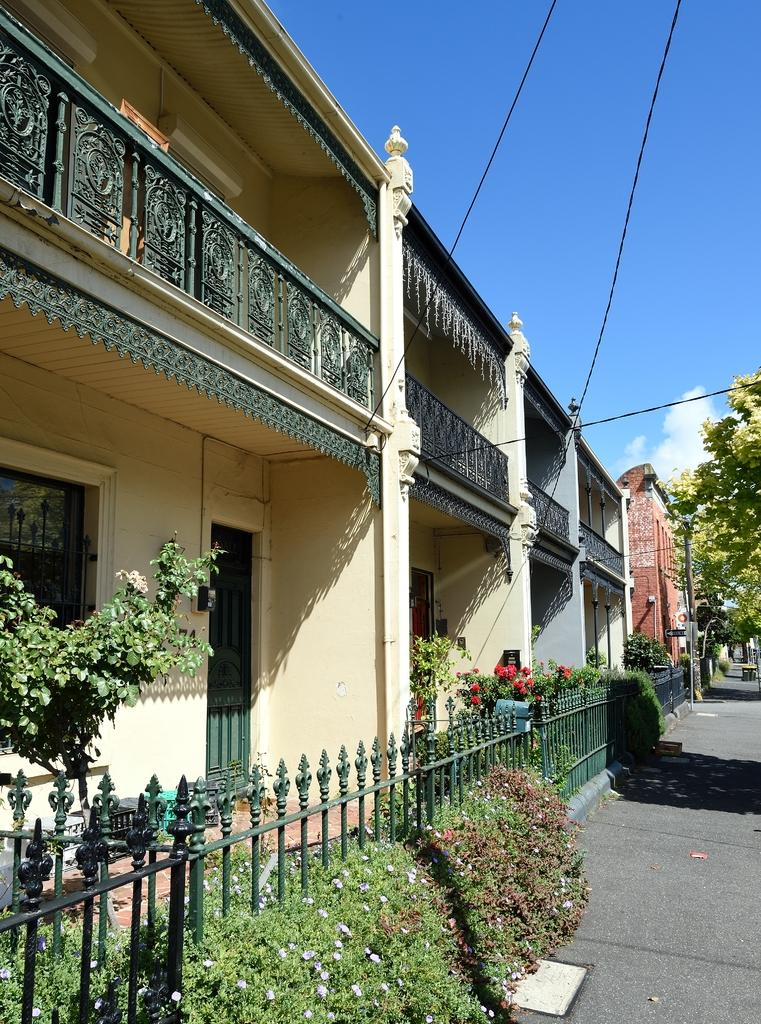What type of structures can be seen in the image? There are houses in the image. What type of vegetation is present in the image? There are trees, plants, and flowers in the image. What type of notebook can be seen in the image? There is no notebook present in the image. Can you see an owl perched on one of the houses in the image? There is no owl present in the image. 